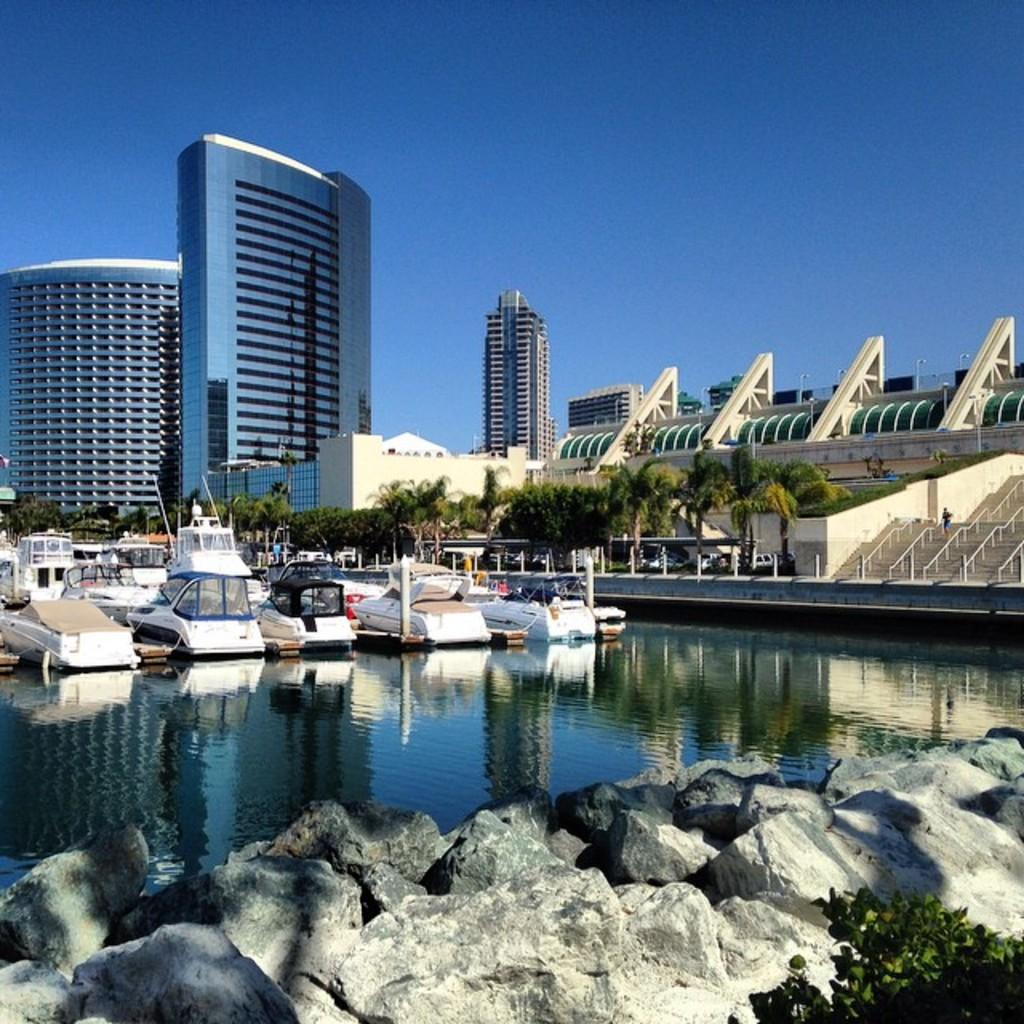What type of buildings can be seen in the image? There are skyscrapers in the image. What is located at the bottom of the image? There are rocks at the bottom of the image. What can be seen on the water in the middle of the image? There are boats on the water in the middle of the image. What is visible at the top of the image? The sky is visible at the top of the image. What type of vegetation is present in the middle of the image? There are trees in the middle of the image. How many deer can be seen comfortably resting on the land in the image? There are no deer present in the image, and the concept of comfort does not apply to the image. 